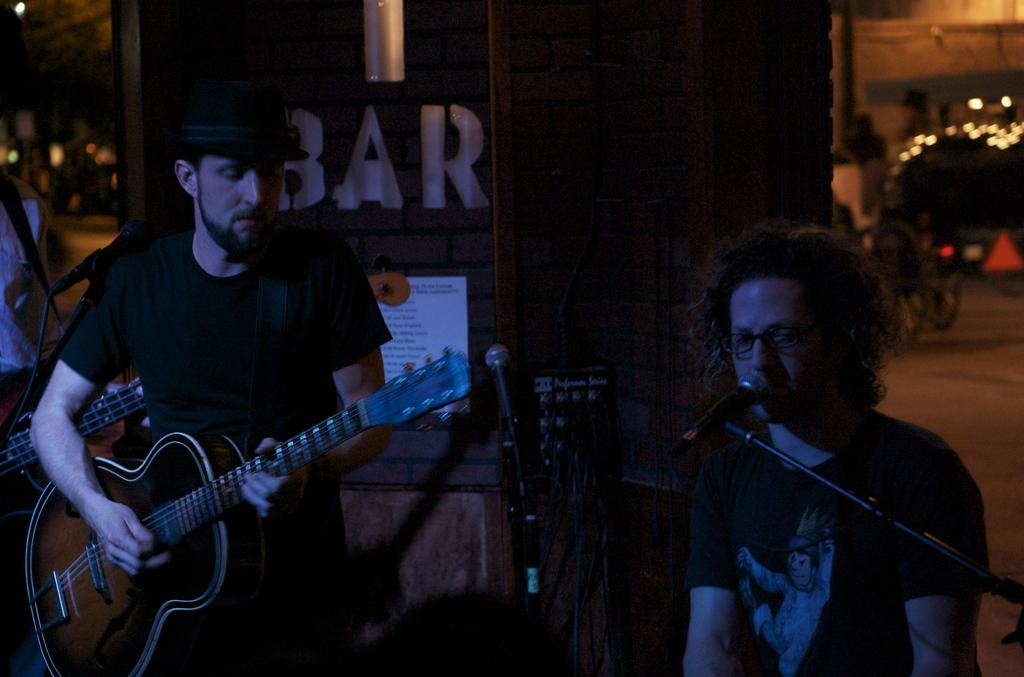Who is the main subject in the image? There is a man in the image. What is the man doing in the image? The man is singing a song. Are there any other people in the image? Yes, there is a boy in the image. What is the boy doing in the image? The boy is playing the guitar. What type of wine is being served in the image? There is no wine present in the image; it features a man singing and a boy playing the guitar. 